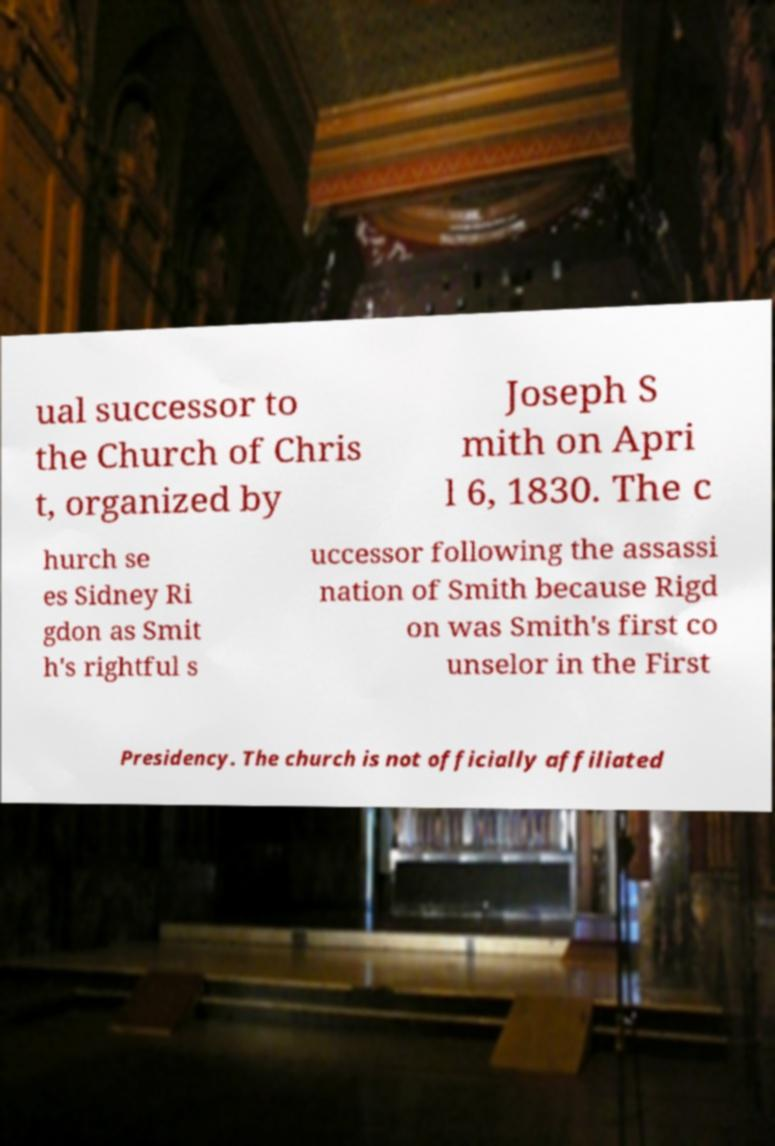Could you assist in decoding the text presented in this image and type it out clearly? ual successor to the Church of Chris t, organized by Joseph S mith on Apri l 6, 1830. The c hurch se es Sidney Ri gdon as Smit h's rightful s uccessor following the assassi nation of Smith because Rigd on was Smith's first co unselor in the First Presidency. The church is not officially affiliated 